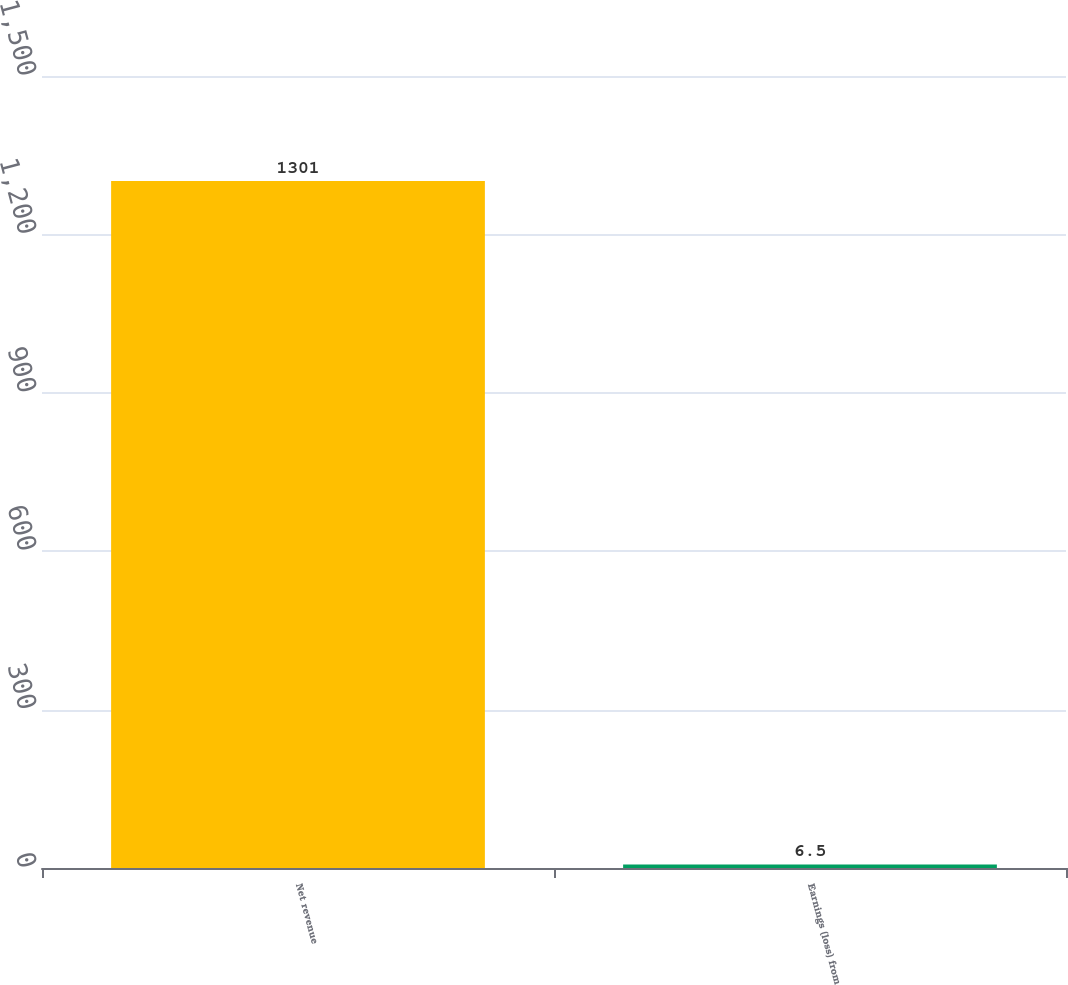Convert chart. <chart><loc_0><loc_0><loc_500><loc_500><bar_chart><fcel>Net revenue<fcel>Earnings (loss) from<nl><fcel>1301<fcel>6.5<nl></chart> 